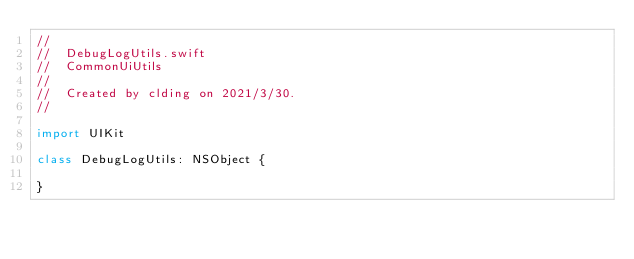<code> <loc_0><loc_0><loc_500><loc_500><_Swift_>//
//  DebugLogUtils.swift
//  CommonUiUtils
//
//  Created by clding on 2021/3/30.
//

import UIKit

class DebugLogUtils: NSObject {

}
</code> 